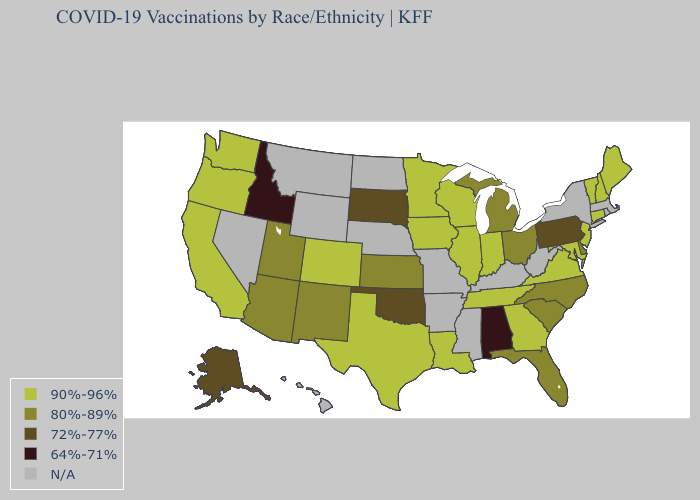What is the value of Oregon?
Be succinct. 90%-96%. Does Delaware have the highest value in the South?
Short answer required. No. Does the first symbol in the legend represent the smallest category?
Write a very short answer. No. Is the legend a continuous bar?
Keep it brief. No. Which states hav the highest value in the MidWest?
Quick response, please. Illinois, Indiana, Iowa, Minnesota, Wisconsin. What is the value of Wisconsin?
Short answer required. 90%-96%. Name the states that have a value in the range 80%-89%?
Give a very brief answer. Arizona, Delaware, Florida, Kansas, Michigan, New Mexico, North Carolina, Ohio, South Carolina, Utah. What is the value of Oklahoma?
Write a very short answer. 72%-77%. Name the states that have a value in the range N/A?
Write a very short answer. Arkansas, Hawaii, Kentucky, Massachusetts, Mississippi, Missouri, Montana, Nebraska, Nevada, New York, North Dakota, Rhode Island, West Virginia, Wyoming. Among the states that border Massachusetts , which have the highest value?
Give a very brief answer. Connecticut, New Hampshire, Vermont. Which states have the lowest value in the West?
Short answer required. Idaho. Which states have the lowest value in the USA?
Write a very short answer. Alabama, Idaho. Name the states that have a value in the range 64%-71%?
Concise answer only. Alabama, Idaho. Name the states that have a value in the range 80%-89%?
Keep it brief. Arizona, Delaware, Florida, Kansas, Michigan, New Mexico, North Carolina, Ohio, South Carolina, Utah. Name the states that have a value in the range 90%-96%?
Answer briefly. California, Colorado, Connecticut, Georgia, Illinois, Indiana, Iowa, Louisiana, Maine, Maryland, Minnesota, New Hampshire, New Jersey, Oregon, Tennessee, Texas, Vermont, Virginia, Washington, Wisconsin. 